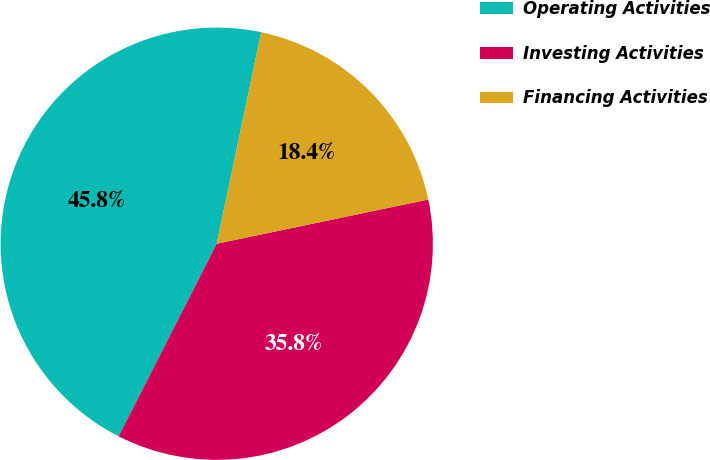<chart> <loc_0><loc_0><loc_500><loc_500><pie_chart><fcel>Operating Activities<fcel>Investing Activities<fcel>Financing Activities<nl><fcel>45.8%<fcel>35.78%<fcel>18.42%<nl></chart> 